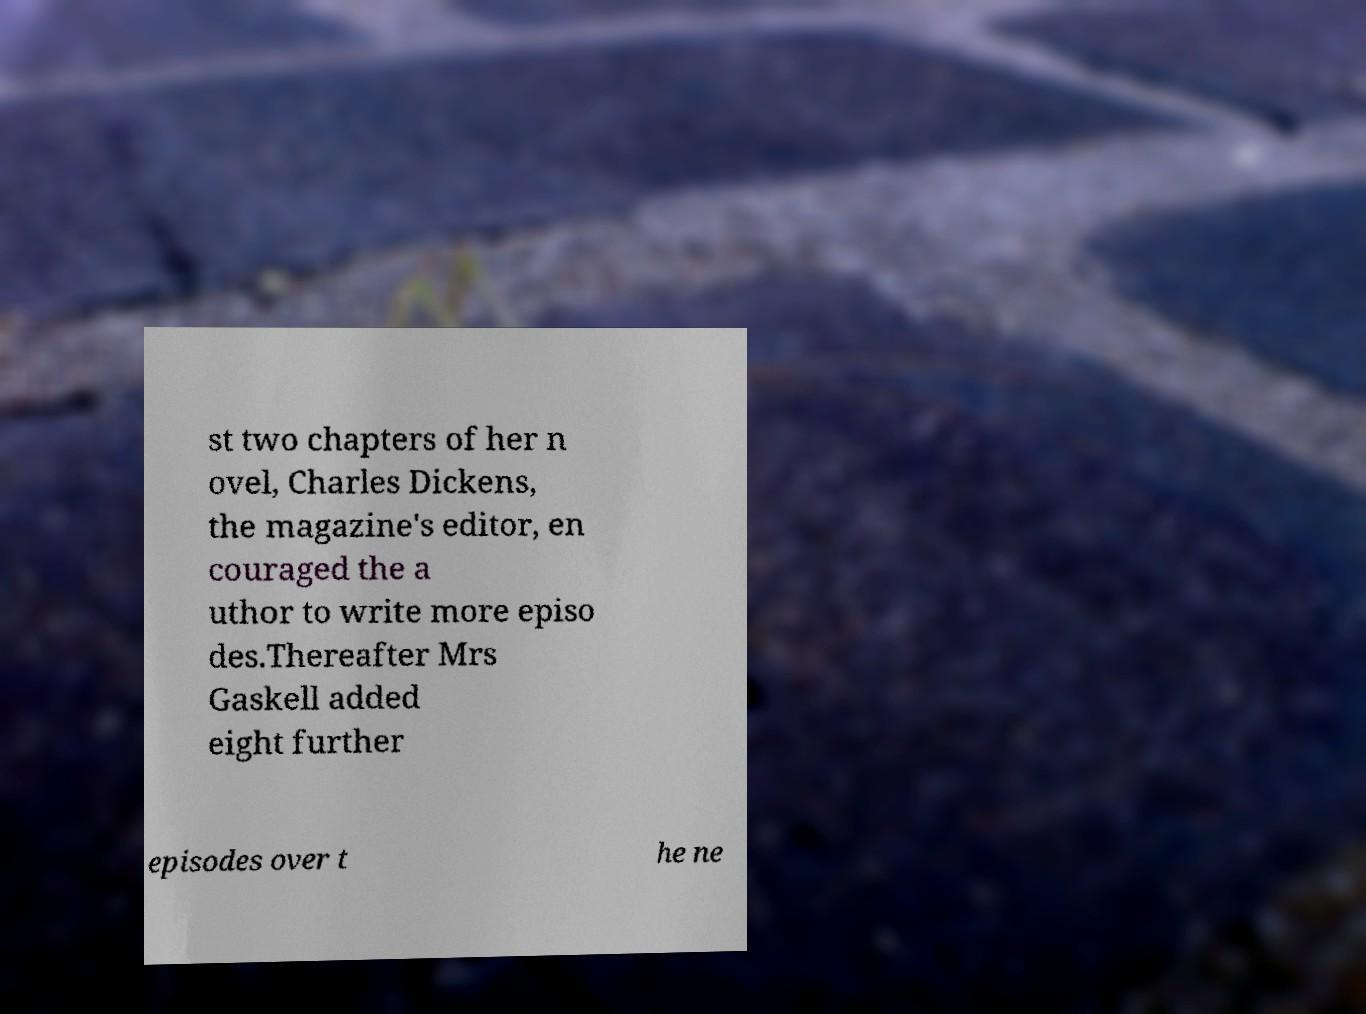Could you extract and type out the text from this image? st two chapters of her n ovel, Charles Dickens, the magazine's editor, en couraged the a uthor to write more episo des.Thereafter Mrs Gaskell added eight further episodes over t he ne 